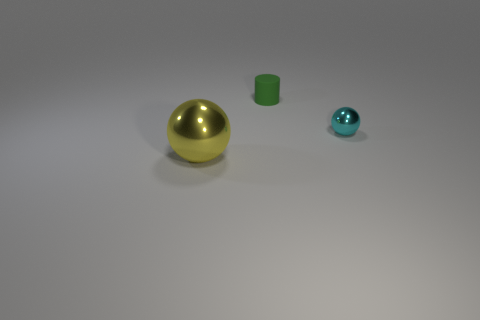Can you describe the positioning of the objects relative to each other? Certainly! In the image, the objects are arranged from left to right based on their size. The largest object, which is a golden metallic sphere, is positioned on the far left. In the middle, there is a small green cube, and on the far right, there is a smaller blue metallic sphere. 